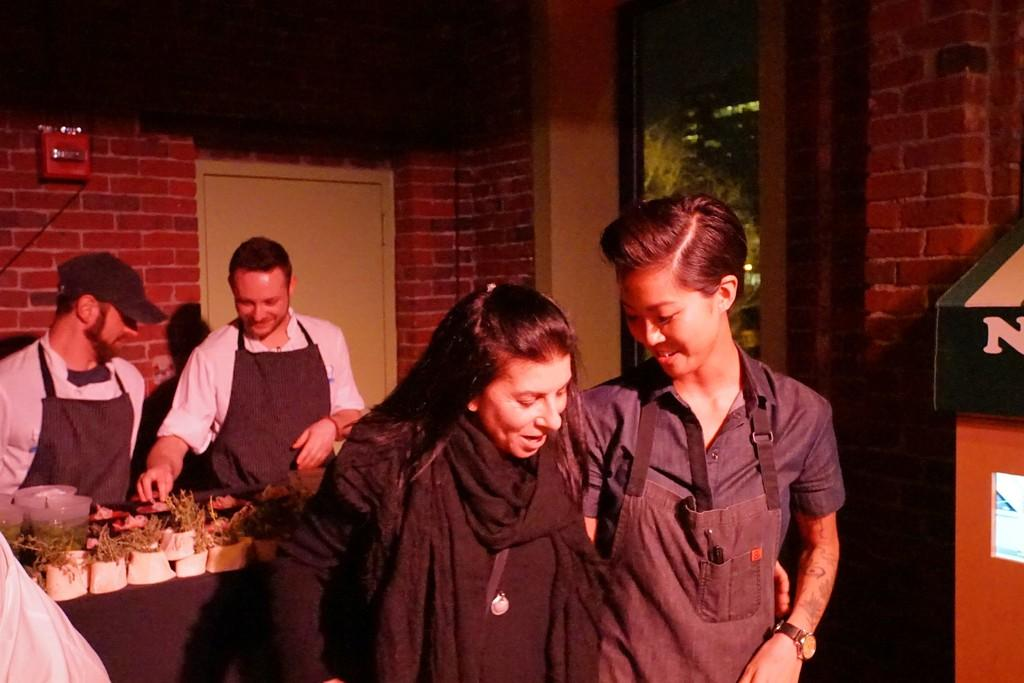What type of structure is visible in the image? There is a brick wall in the image. What object can be used for self-reflection or checking appearance? There is a mirror in the image. What feature in the image allows access to another space? There is a door in the image. Who or what can be seen in the image? There are people in the image. What piece of furniture is present in the image? There is a table in the image. What is covering the table in the image? There is a black color cloth on the table. What type of living organisms are on the table in the image? There are plants on the table. What type of fuel is being used by the people in the image? There is no mention of fuel or any fuel-related activity in the image. How many times did the people smash the table in the image? There is no indication of any smashing or destructive behavior in the image. 